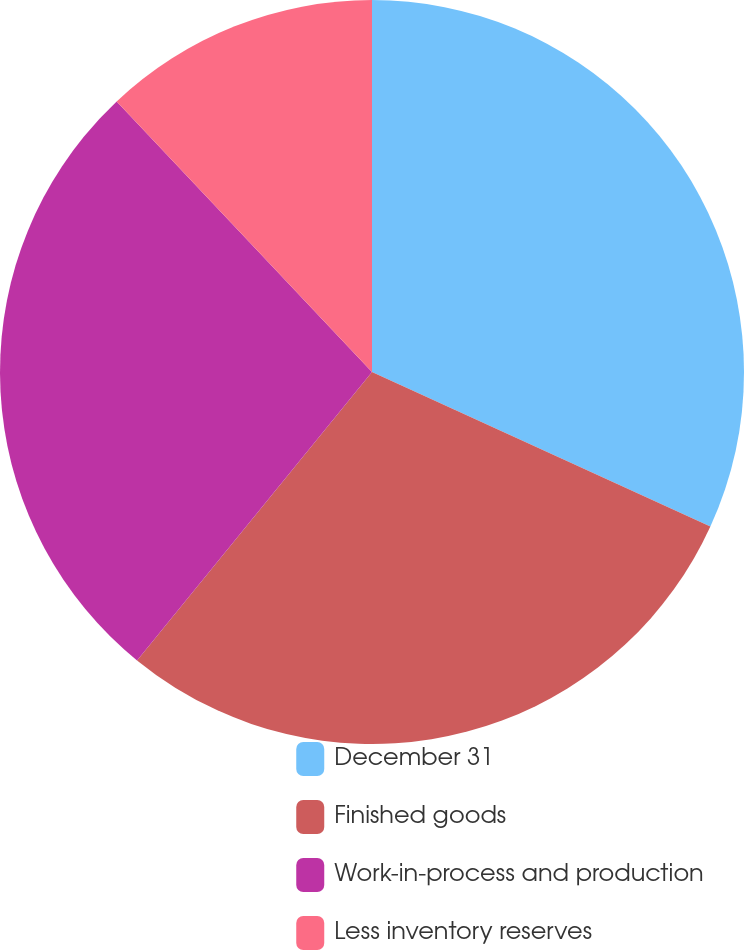Convert chart to OTSL. <chart><loc_0><loc_0><loc_500><loc_500><pie_chart><fcel>December 31<fcel>Finished goods<fcel>Work-in-process and production<fcel>Less inventory reserves<nl><fcel>31.82%<fcel>29.06%<fcel>27.08%<fcel>12.04%<nl></chart> 